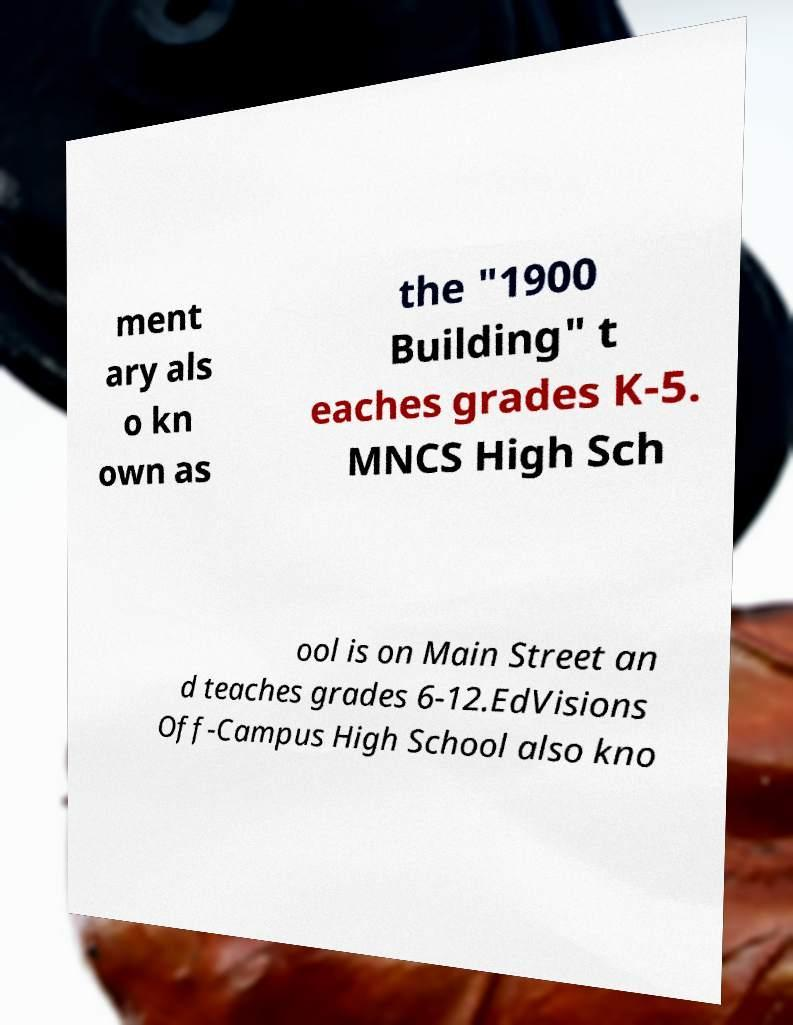Can you read and provide the text displayed in the image?This photo seems to have some interesting text. Can you extract and type it out for me? ment ary als o kn own as the "1900 Building" t eaches grades K-5. MNCS High Sch ool is on Main Street an d teaches grades 6-12.EdVisions Off-Campus High School also kno 